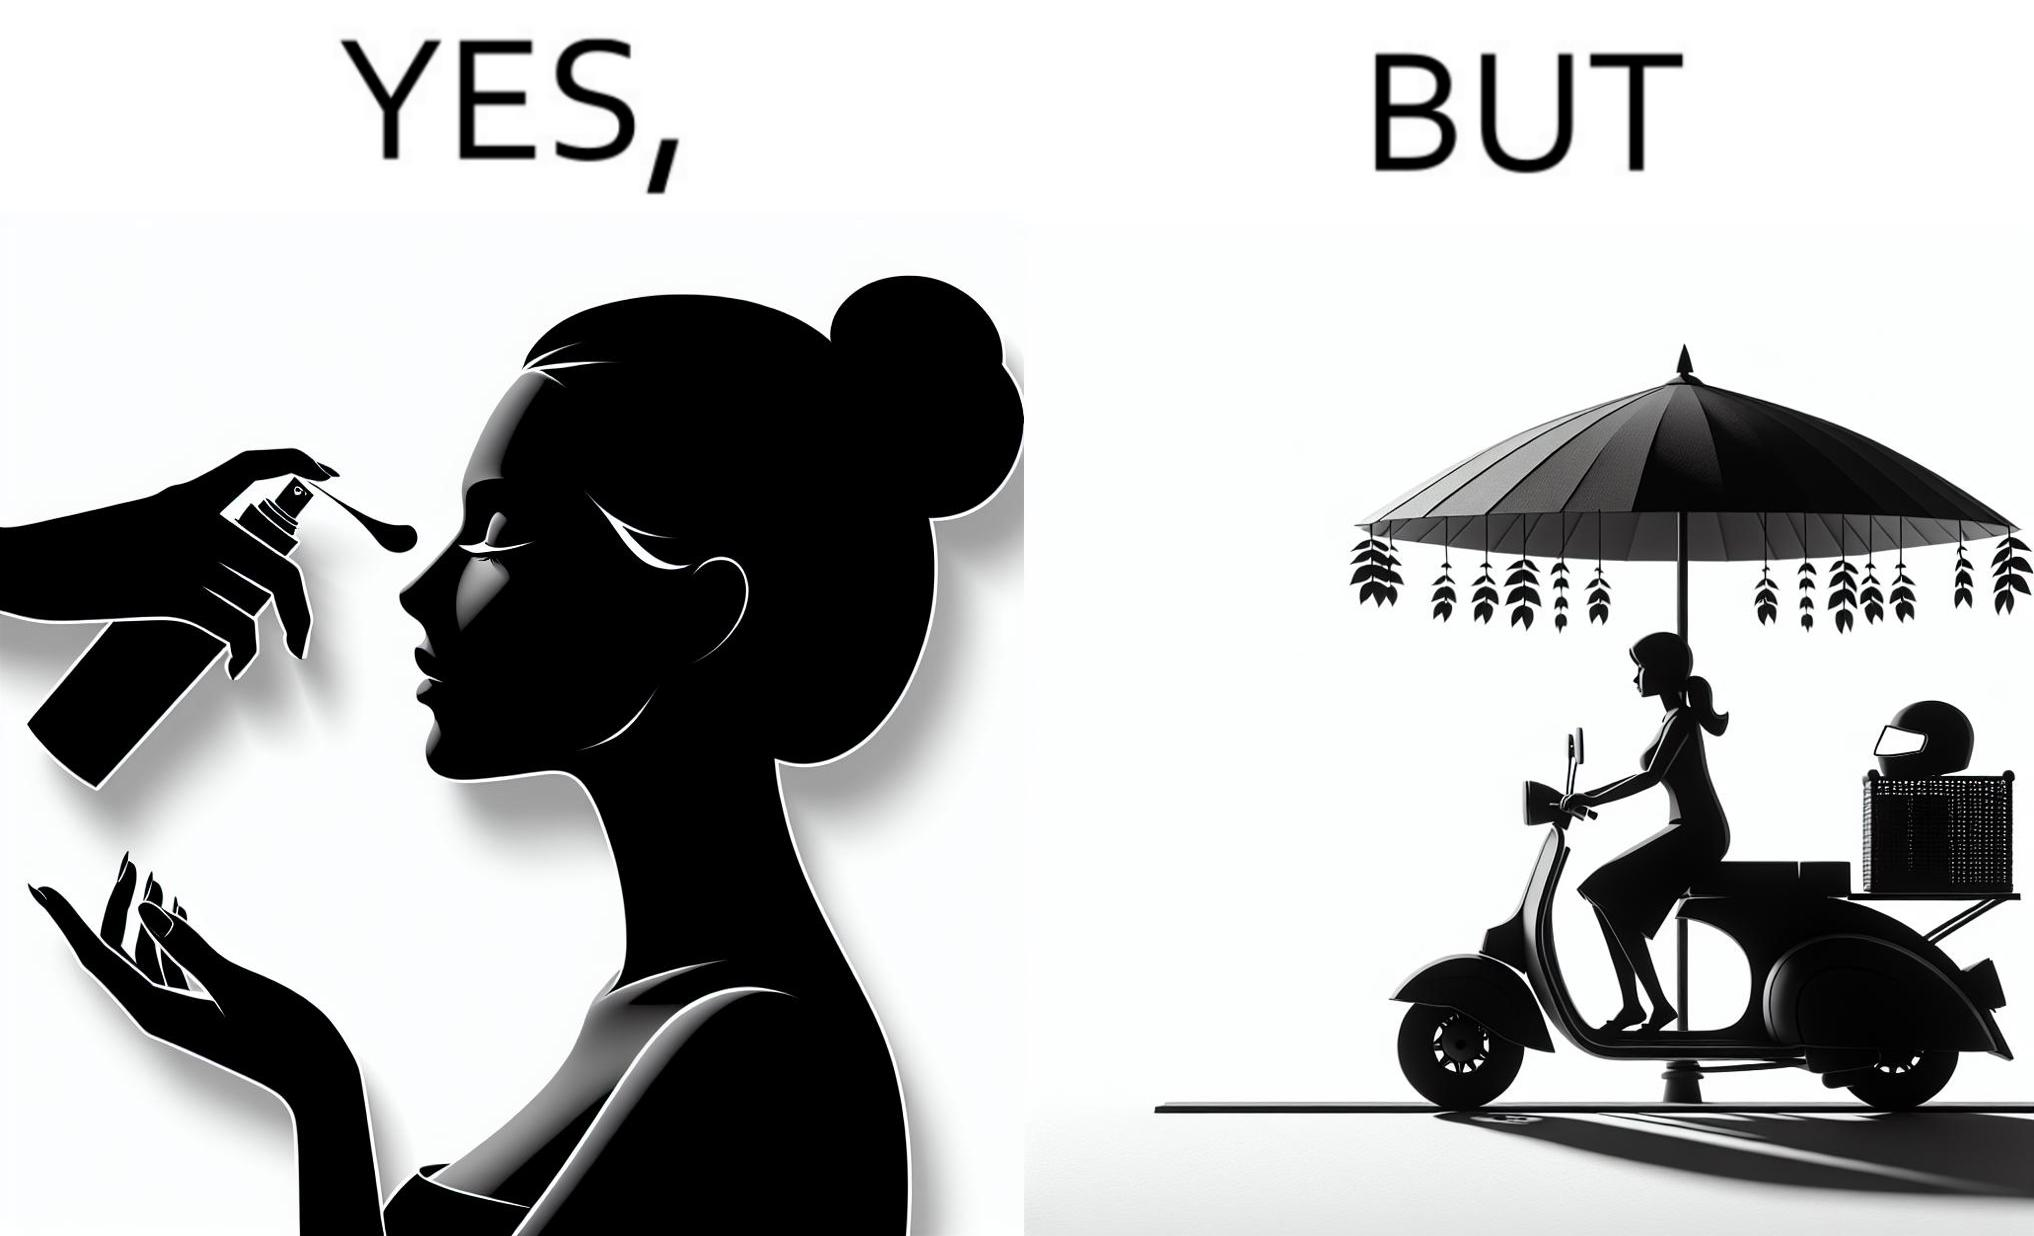What is shown in the left half versus the right half of this image? In the left part of the image: The image shows a woman applying sunscreen with high SPF on her face. In the right part of the image: The image shows a woman riding a scooter with her helmet on the back seat. 